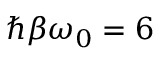<formula> <loc_0><loc_0><loc_500><loc_500>\hbar { \beta } \omega _ { 0 } = 6</formula> 